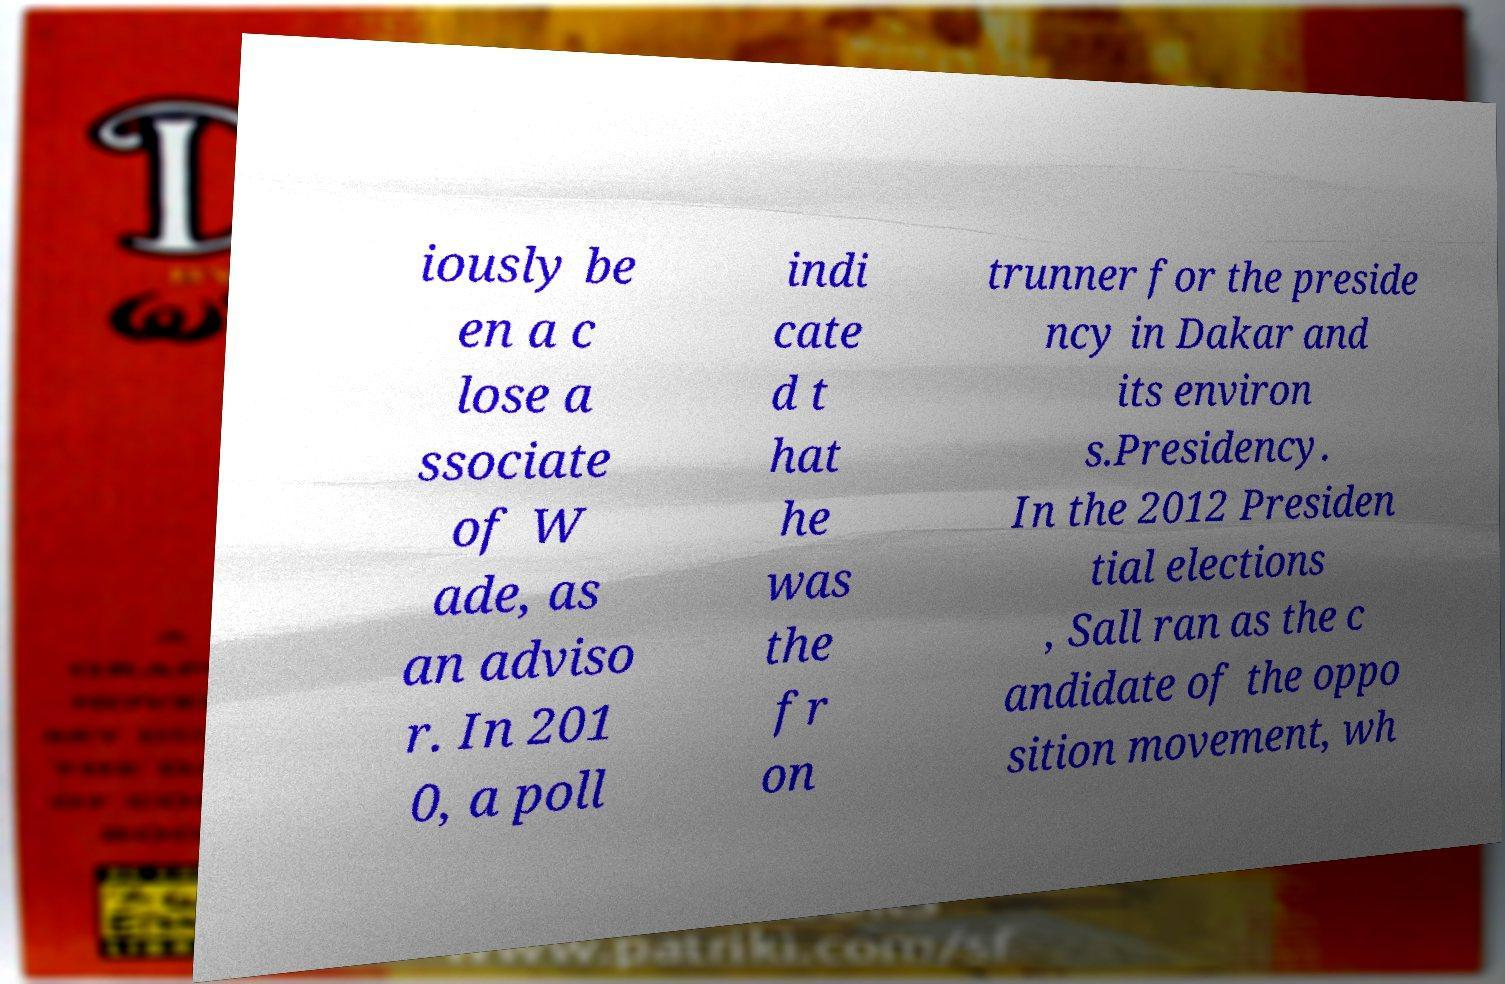Can you read and provide the text displayed in the image?This photo seems to have some interesting text. Can you extract and type it out for me? iously be en a c lose a ssociate of W ade, as an adviso r. In 201 0, a poll indi cate d t hat he was the fr on trunner for the preside ncy in Dakar and its environ s.Presidency. In the 2012 Presiden tial elections , Sall ran as the c andidate of the oppo sition movement, wh 